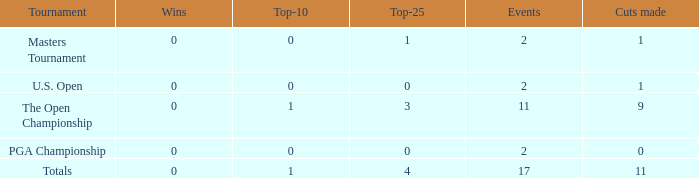What is his greatest amount of top 25s when he took part in over 2 events and below 1 win? None. 